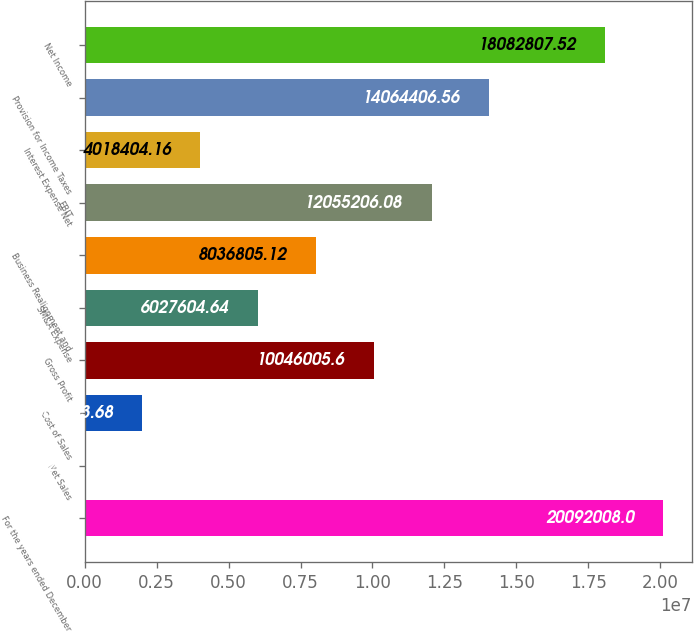Convert chart. <chart><loc_0><loc_0><loc_500><loc_500><bar_chart><fcel>For the years ended December<fcel>Net Sales<fcel>Cost of Sales<fcel>Gross Profit<fcel>SM&A Expense<fcel>Business Realignment and<fcel>EBIT<fcel>Interest Expense Net<fcel>Provision for Income Taxes<fcel>Net Income<nl><fcel>2.0092e+07<fcel>3.2<fcel>2.0092e+06<fcel>1.0046e+07<fcel>6.0276e+06<fcel>8.03681e+06<fcel>1.20552e+07<fcel>4.0184e+06<fcel>1.40644e+07<fcel>1.80828e+07<nl></chart> 